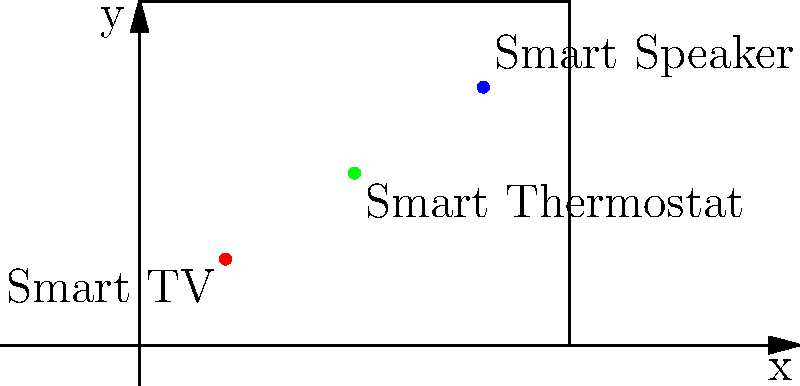In your smart home floor plan represented by a 2D coordinate system, you've placed three IoT devices: a Smart TV at $(2,2)$, a Smart Speaker at $(8,6)$, and a Smart Thermostat at $(5,4)$. What is the total distance between all three devices, rounded to the nearest integer? To find the total distance between all three devices, we need to calculate the distances between each pair and sum them up. Let's break it down step-by-step:

1. Calculate the distance between Smart TV and Smart Speaker:
   Use the distance formula: $d = \sqrt{(x_2-x_1)^2 + (y_2-y_1)^2}$
   $d_{TV-Speaker} = \sqrt{(8-2)^2 + (6-2)^2} = \sqrt{36 + 16} = \sqrt{52} \approx 7.21$

2. Calculate the distance between Smart Speaker and Smart Thermostat:
   $d_{Speaker-Thermostat} = \sqrt{(5-8)^2 + (4-6)^2} = \sqrt{9 + 4} = \sqrt{13} \approx 3.61$

3. Calculate the distance between Smart Thermostat and Smart TV:
   $d_{Thermostat-TV} = \sqrt{(2-5)^2 + (2-4)^2} = \sqrt{9 + 4} = \sqrt{13} \approx 3.61$

4. Sum up all distances:
   Total distance = $7.21 + 3.61 + 3.61 = 14.43$

5. Round to the nearest integer:
   $14.43 \approx 14$

Therefore, the total distance between all three devices, rounded to the nearest integer, is 14 units.
Answer: 14 